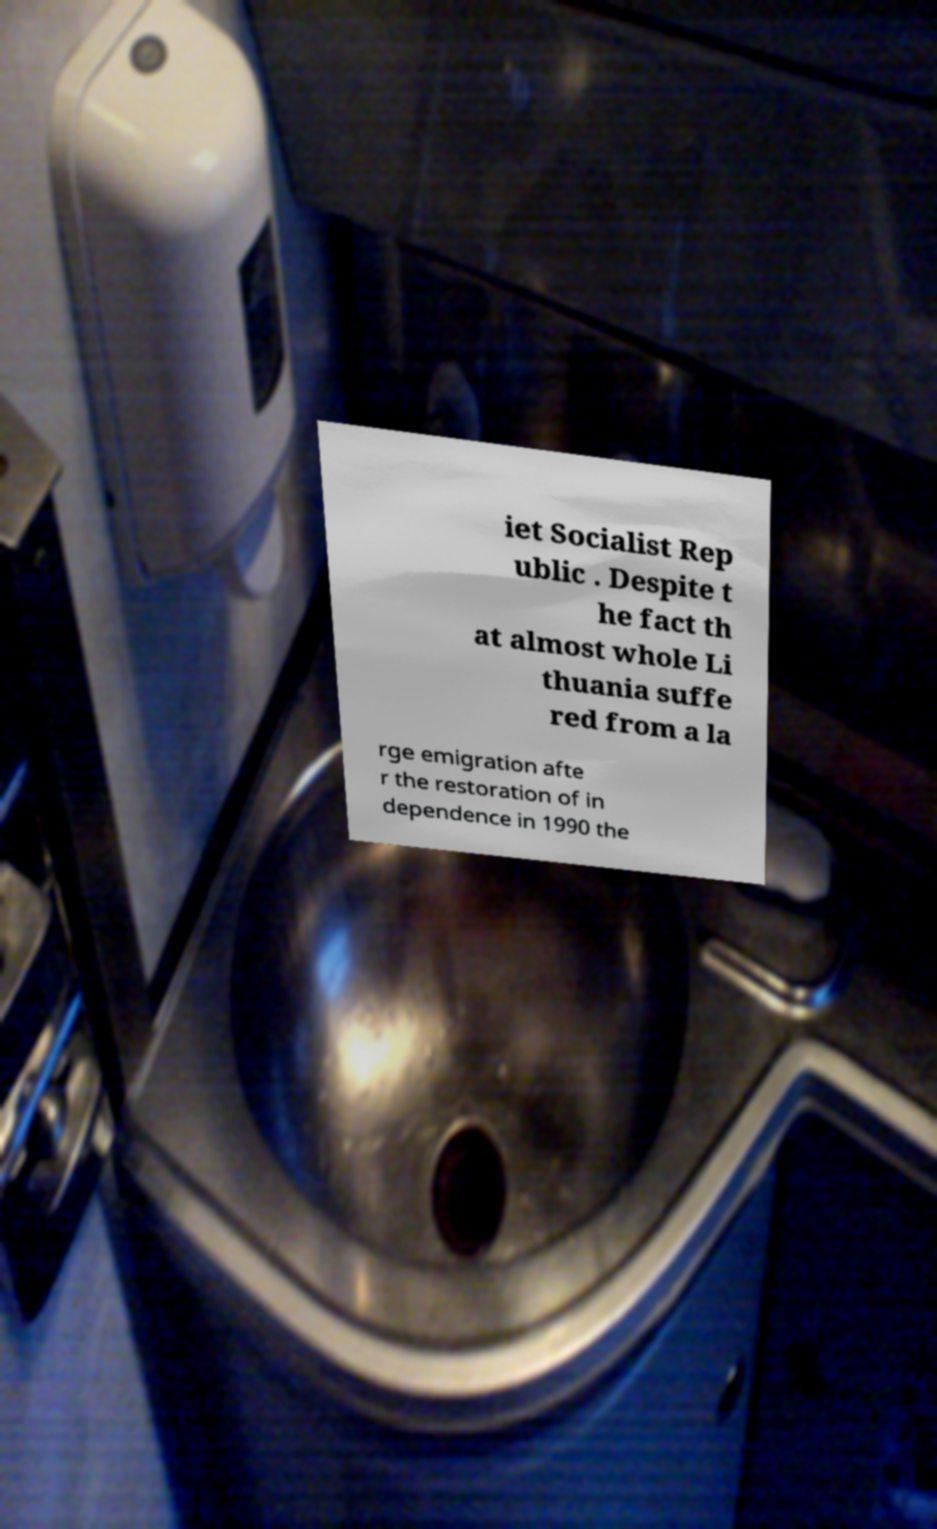Please identify and transcribe the text found in this image. iet Socialist Rep ublic . Despite t he fact th at almost whole Li thuania suffe red from a la rge emigration afte r the restoration of in dependence in 1990 the 